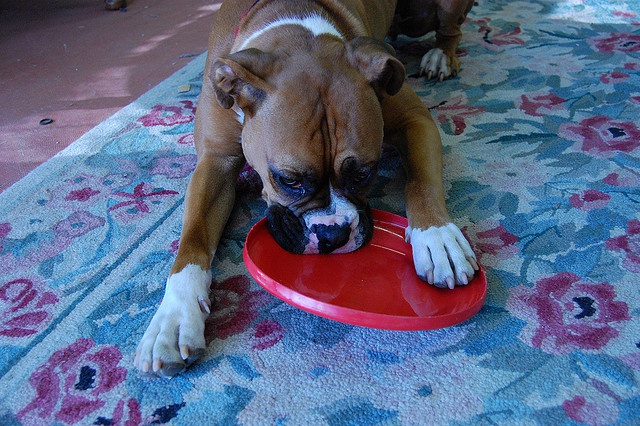Describe the objects in this image and their specific colors. I can see dog in black, gray, and darkgray tones and frisbee in black, maroon, and brown tones in this image. 